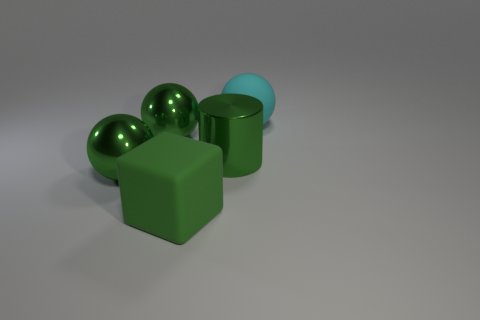What color is the rubber thing that is the same size as the cyan rubber sphere?
Keep it short and to the point. Green. Is the number of large cyan spheres that are behind the rubber sphere less than the number of large green metal things left of the big rubber cube?
Your response must be concise. Yes. What is the shape of the large rubber thing that is to the left of the large sphere to the right of the large rubber object that is in front of the big rubber ball?
Keep it short and to the point. Cube. There is a large matte object that is in front of the large cyan matte object; is its color the same as the rubber thing behind the big metallic cylinder?
Give a very brief answer. No. The large rubber thing that is the same color as the big metal cylinder is what shape?
Give a very brief answer. Cube. What number of rubber things are green spheres or purple cylinders?
Keep it short and to the point. 0. What is the color of the metallic thing that is on the right side of the rubber object that is in front of the matte object behind the large block?
Offer a very short reply. Green. Are there any other things that are the same color as the block?
Your response must be concise. Yes. What number of other objects are the same material as the block?
Your answer should be very brief. 1. What size is the shiny cylinder?
Ensure brevity in your answer.  Large. 